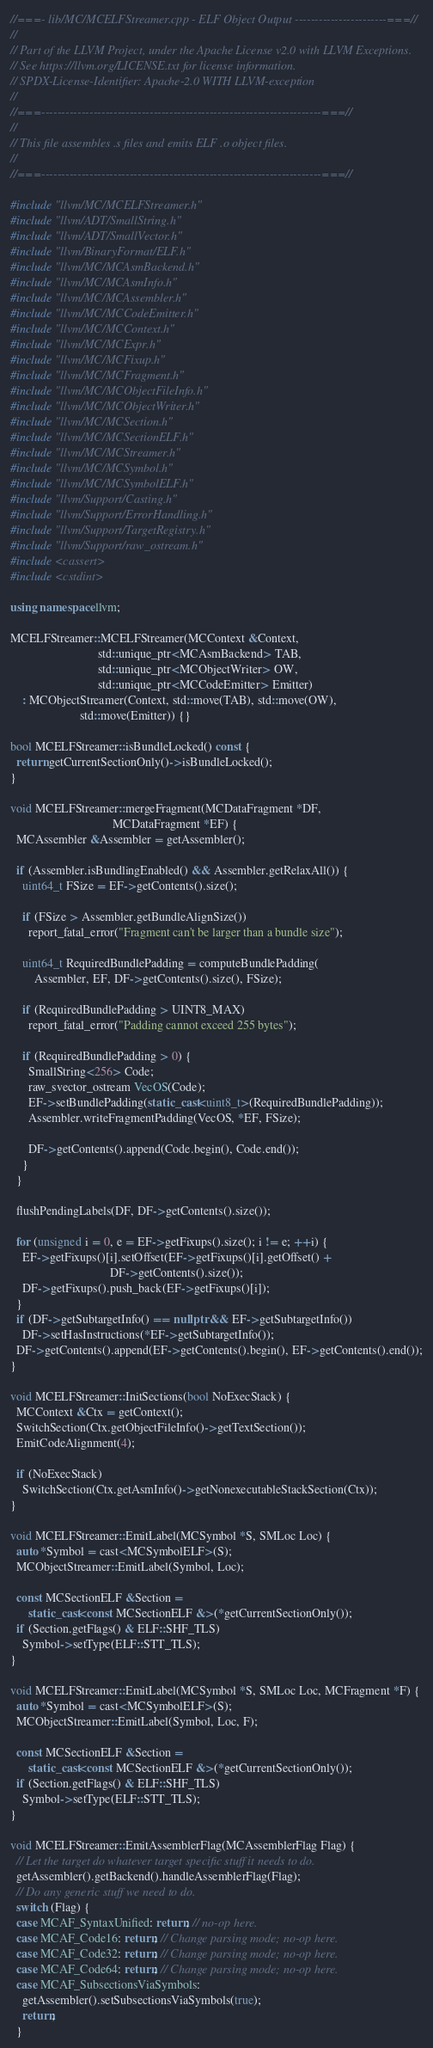<code> <loc_0><loc_0><loc_500><loc_500><_C++_>//===- lib/MC/MCELFStreamer.cpp - ELF Object Output -----------------------===//
//
// Part of the LLVM Project, under the Apache License v2.0 with LLVM Exceptions.
// See https://llvm.org/LICENSE.txt for license information.
// SPDX-License-Identifier: Apache-2.0 WITH LLVM-exception
//
//===----------------------------------------------------------------------===//
//
// This file assembles .s files and emits ELF .o object files.
//
//===----------------------------------------------------------------------===//

#include "llvm/MC/MCELFStreamer.h"
#include "llvm/ADT/SmallString.h"
#include "llvm/ADT/SmallVector.h"
#include "llvm/BinaryFormat/ELF.h"
#include "llvm/MC/MCAsmBackend.h"
#include "llvm/MC/MCAsmInfo.h"
#include "llvm/MC/MCAssembler.h"
#include "llvm/MC/MCCodeEmitter.h"
#include "llvm/MC/MCContext.h"
#include "llvm/MC/MCExpr.h"
#include "llvm/MC/MCFixup.h"
#include "llvm/MC/MCFragment.h"
#include "llvm/MC/MCObjectFileInfo.h"
#include "llvm/MC/MCObjectWriter.h"
#include "llvm/MC/MCSection.h"
#include "llvm/MC/MCSectionELF.h"
#include "llvm/MC/MCStreamer.h"
#include "llvm/MC/MCSymbol.h"
#include "llvm/MC/MCSymbolELF.h"
#include "llvm/Support/Casting.h"
#include "llvm/Support/ErrorHandling.h"
#include "llvm/Support/TargetRegistry.h"
#include "llvm/Support/raw_ostream.h"
#include <cassert>
#include <cstdint>

using namespace llvm;

MCELFStreamer::MCELFStreamer(MCContext &Context,
                             std::unique_ptr<MCAsmBackend> TAB,
                             std::unique_ptr<MCObjectWriter> OW,
                             std::unique_ptr<MCCodeEmitter> Emitter)
    : MCObjectStreamer(Context, std::move(TAB), std::move(OW),
                       std::move(Emitter)) {}

bool MCELFStreamer::isBundleLocked() const {
  return getCurrentSectionOnly()->isBundleLocked();
}

void MCELFStreamer::mergeFragment(MCDataFragment *DF,
                                  MCDataFragment *EF) {
  MCAssembler &Assembler = getAssembler();

  if (Assembler.isBundlingEnabled() && Assembler.getRelaxAll()) {
    uint64_t FSize = EF->getContents().size();

    if (FSize > Assembler.getBundleAlignSize())
      report_fatal_error("Fragment can't be larger than a bundle size");

    uint64_t RequiredBundlePadding = computeBundlePadding(
        Assembler, EF, DF->getContents().size(), FSize);

    if (RequiredBundlePadding > UINT8_MAX)
      report_fatal_error("Padding cannot exceed 255 bytes");

    if (RequiredBundlePadding > 0) {
      SmallString<256> Code;
      raw_svector_ostream VecOS(Code);
      EF->setBundlePadding(static_cast<uint8_t>(RequiredBundlePadding));
      Assembler.writeFragmentPadding(VecOS, *EF, FSize);

      DF->getContents().append(Code.begin(), Code.end());
    }
  }

  flushPendingLabels(DF, DF->getContents().size());

  for (unsigned i = 0, e = EF->getFixups().size(); i != e; ++i) {
    EF->getFixups()[i].setOffset(EF->getFixups()[i].getOffset() +
                                 DF->getContents().size());
    DF->getFixups().push_back(EF->getFixups()[i]);
  }
  if (DF->getSubtargetInfo() == nullptr && EF->getSubtargetInfo())
    DF->setHasInstructions(*EF->getSubtargetInfo());
  DF->getContents().append(EF->getContents().begin(), EF->getContents().end());
}

void MCELFStreamer::InitSections(bool NoExecStack) {
  MCContext &Ctx = getContext();
  SwitchSection(Ctx.getObjectFileInfo()->getTextSection());
  EmitCodeAlignment(4);

  if (NoExecStack)
    SwitchSection(Ctx.getAsmInfo()->getNonexecutableStackSection(Ctx));
}

void MCELFStreamer::EmitLabel(MCSymbol *S, SMLoc Loc) {
  auto *Symbol = cast<MCSymbolELF>(S);
  MCObjectStreamer::EmitLabel(Symbol, Loc);

  const MCSectionELF &Section =
      static_cast<const MCSectionELF &>(*getCurrentSectionOnly());
  if (Section.getFlags() & ELF::SHF_TLS)
    Symbol->setType(ELF::STT_TLS);
}

void MCELFStreamer::EmitLabel(MCSymbol *S, SMLoc Loc, MCFragment *F) {
  auto *Symbol = cast<MCSymbolELF>(S);
  MCObjectStreamer::EmitLabel(Symbol, Loc, F);

  const MCSectionELF &Section =
      static_cast<const MCSectionELF &>(*getCurrentSectionOnly());
  if (Section.getFlags() & ELF::SHF_TLS)
    Symbol->setType(ELF::STT_TLS);
}

void MCELFStreamer::EmitAssemblerFlag(MCAssemblerFlag Flag) {
  // Let the target do whatever target specific stuff it needs to do.
  getAssembler().getBackend().handleAssemblerFlag(Flag);
  // Do any generic stuff we need to do.
  switch (Flag) {
  case MCAF_SyntaxUnified: return; // no-op here.
  case MCAF_Code16: return; // Change parsing mode; no-op here.
  case MCAF_Code32: return; // Change parsing mode; no-op here.
  case MCAF_Code64: return; // Change parsing mode; no-op here.
  case MCAF_SubsectionsViaSymbols:
    getAssembler().setSubsectionsViaSymbols(true);
    return;
  }
</code> 